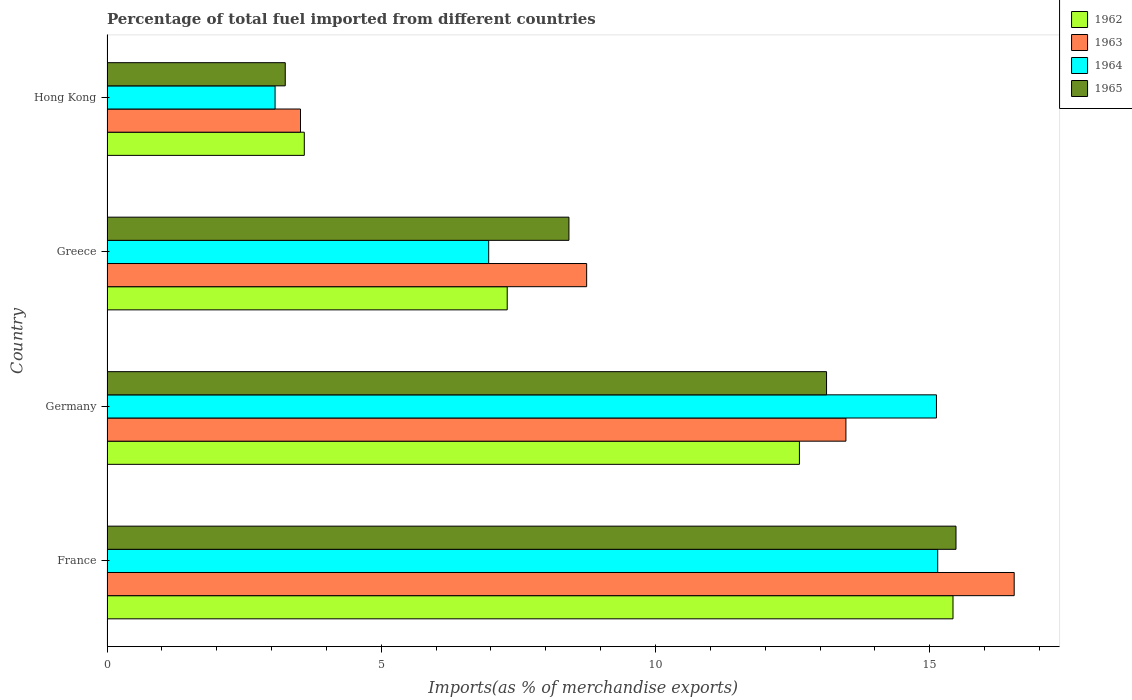How many different coloured bars are there?
Offer a very short reply. 4. How many groups of bars are there?
Your response must be concise. 4. Are the number of bars per tick equal to the number of legend labels?
Your answer should be very brief. Yes. How many bars are there on the 3rd tick from the top?
Keep it short and to the point. 4. How many bars are there on the 4th tick from the bottom?
Make the answer very short. 4. What is the label of the 1st group of bars from the top?
Offer a very short reply. Hong Kong. What is the percentage of imports to different countries in 1965 in France?
Keep it short and to the point. 15.48. Across all countries, what is the maximum percentage of imports to different countries in 1965?
Offer a very short reply. 15.48. Across all countries, what is the minimum percentage of imports to different countries in 1962?
Your response must be concise. 3.6. In which country was the percentage of imports to different countries in 1962 minimum?
Provide a short and direct response. Hong Kong. What is the total percentage of imports to different countries in 1962 in the graph?
Your answer should be very brief. 38.94. What is the difference between the percentage of imports to different countries in 1962 in Germany and that in Greece?
Your answer should be compact. 5.33. What is the difference between the percentage of imports to different countries in 1963 in Hong Kong and the percentage of imports to different countries in 1962 in Germany?
Offer a very short reply. -9.1. What is the average percentage of imports to different countries in 1963 per country?
Provide a short and direct response. 10.57. What is the difference between the percentage of imports to different countries in 1963 and percentage of imports to different countries in 1962 in Greece?
Keep it short and to the point. 1.45. In how many countries, is the percentage of imports to different countries in 1964 greater than 12 %?
Your answer should be compact. 2. What is the ratio of the percentage of imports to different countries in 1962 in France to that in Germany?
Provide a short and direct response. 1.22. What is the difference between the highest and the second highest percentage of imports to different countries in 1963?
Your answer should be compact. 3.07. What is the difference between the highest and the lowest percentage of imports to different countries in 1964?
Ensure brevity in your answer.  12.08. In how many countries, is the percentage of imports to different countries in 1965 greater than the average percentage of imports to different countries in 1965 taken over all countries?
Your answer should be compact. 2. What does the 3rd bar from the top in France represents?
Your answer should be very brief. 1963. What does the 4th bar from the bottom in Hong Kong represents?
Make the answer very short. 1965. Are all the bars in the graph horizontal?
Offer a very short reply. Yes. Are the values on the major ticks of X-axis written in scientific E-notation?
Offer a very short reply. No. Does the graph contain grids?
Ensure brevity in your answer.  No. How many legend labels are there?
Give a very brief answer. 4. How are the legend labels stacked?
Provide a short and direct response. Vertical. What is the title of the graph?
Offer a terse response. Percentage of total fuel imported from different countries. What is the label or title of the X-axis?
Provide a short and direct response. Imports(as % of merchandise exports). What is the Imports(as % of merchandise exports) of 1962 in France?
Your answer should be compact. 15.42. What is the Imports(as % of merchandise exports) of 1963 in France?
Make the answer very short. 16.54. What is the Imports(as % of merchandise exports) in 1964 in France?
Provide a succinct answer. 15.14. What is the Imports(as % of merchandise exports) of 1965 in France?
Ensure brevity in your answer.  15.48. What is the Imports(as % of merchandise exports) in 1962 in Germany?
Your response must be concise. 12.62. What is the Imports(as % of merchandise exports) in 1963 in Germany?
Give a very brief answer. 13.47. What is the Imports(as % of merchandise exports) of 1964 in Germany?
Make the answer very short. 15.12. What is the Imports(as % of merchandise exports) of 1965 in Germany?
Your answer should be very brief. 13.12. What is the Imports(as % of merchandise exports) of 1962 in Greece?
Offer a terse response. 7.3. What is the Imports(as % of merchandise exports) of 1963 in Greece?
Provide a short and direct response. 8.74. What is the Imports(as % of merchandise exports) of 1964 in Greece?
Make the answer very short. 6.96. What is the Imports(as % of merchandise exports) in 1965 in Greece?
Your response must be concise. 8.42. What is the Imports(as % of merchandise exports) in 1962 in Hong Kong?
Give a very brief answer. 3.6. What is the Imports(as % of merchandise exports) of 1963 in Hong Kong?
Your answer should be very brief. 3.53. What is the Imports(as % of merchandise exports) of 1964 in Hong Kong?
Your answer should be compact. 3.06. What is the Imports(as % of merchandise exports) in 1965 in Hong Kong?
Provide a short and direct response. 3.25. Across all countries, what is the maximum Imports(as % of merchandise exports) of 1962?
Offer a terse response. 15.42. Across all countries, what is the maximum Imports(as % of merchandise exports) of 1963?
Provide a succinct answer. 16.54. Across all countries, what is the maximum Imports(as % of merchandise exports) of 1964?
Give a very brief answer. 15.14. Across all countries, what is the maximum Imports(as % of merchandise exports) of 1965?
Ensure brevity in your answer.  15.48. Across all countries, what is the minimum Imports(as % of merchandise exports) of 1962?
Offer a very short reply. 3.6. Across all countries, what is the minimum Imports(as % of merchandise exports) of 1963?
Your answer should be compact. 3.53. Across all countries, what is the minimum Imports(as % of merchandise exports) of 1964?
Make the answer very short. 3.06. Across all countries, what is the minimum Imports(as % of merchandise exports) in 1965?
Make the answer very short. 3.25. What is the total Imports(as % of merchandise exports) of 1962 in the graph?
Offer a terse response. 38.94. What is the total Imports(as % of merchandise exports) in 1963 in the graph?
Make the answer very short. 42.28. What is the total Imports(as % of merchandise exports) in 1964 in the graph?
Keep it short and to the point. 40.29. What is the total Imports(as % of merchandise exports) of 1965 in the graph?
Your answer should be compact. 40.26. What is the difference between the Imports(as % of merchandise exports) in 1962 in France and that in Germany?
Give a very brief answer. 2.8. What is the difference between the Imports(as % of merchandise exports) of 1963 in France and that in Germany?
Keep it short and to the point. 3.07. What is the difference between the Imports(as % of merchandise exports) in 1964 in France and that in Germany?
Your answer should be very brief. 0.02. What is the difference between the Imports(as % of merchandise exports) of 1965 in France and that in Germany?
Your answer should be compact. 2.36. What is the difference between the Imports(as % of merchandise exports) in 1962 in France and that in Greece?
Your answer should be compact. 8.13. What is the difference between the Imports(as % of merchandise exports) in 1963 in France and that in Greece?
Give a very brief answer. 7.79. What is the difference between the Imports(as % of merchandise exports) of 1964 in France and that in Greece?
Make the answer very short. 8.19. What is the difference between the Imports(as % of merchandise exports) of 1965 in France and that in Greece?
Give a very brief answer. 7.06. What is the difference between the Imports(as % of merchandise exports) of 1962 in France and that in Hong Kong?
Keep it short and to the point. 11.83. What is the difference between the Imports(as % of merchandise exports) of 1963 in France and that in Hong Kong?
Your response must be concise. 13.01. What is the difference between the Imports(as % of merchandise exports) of 1964 in France and that in Hong Kong?
Ensure brevity in your answer.  12.08. What is the difference between the Imports(as % of merchandise exports) in 1965 in France and that in Hong Kong?
Make the answer very short. 12.23. What is the difference between the Imports(as % of merchandise exports) of 1962 in Germany and that in Greece?
Offer a very short reply. 5.33. What is the difference between the Imports(as % of merchandise exports) of 1963 in Germany and that in Greece?
Keep it short and to the point. 4.73. What is the difference between the Imports(as % of merchandise exports) of 1964 in Germany and that in Greece?
Your answer should be very brief. 8.16. What is the difference between the Imports(as % of merchandise exports) in 1965 in Germany and that in Greece?
Provide a short and direct response. 4.7. What is the difference between the Imports(as % of merchandise exports) in 1962 in Germany and that in Hong Kong?
Your answer should be compact. 9.03. What is the difference between the Imports(as % of merchandise exports) of 1963 in Germany and that in Hong Kong?
Provide a succinct answer. 9.94. What is the difference between the Imports(as % of merchandise exports) in 1964 in Germany and that in Hong Kong?
Keep it short and to the point. 12.06. What is the difference between the Imports(as % of merchandise exports) in 1965 in Germany and that in Hong Kong?
Offer a very short reply. 9.87. What is the difference between the Imports(as % of merchandise exports) of 1962 in Greece and that in Hong Kong?
Make the answer very short. 3.7. What is the difference between the Imports(as % of merchandise exports) in 1963 in Greece and that in Hong Kong?
Your response must be concise. 5.22. What is the difference between the Imports(as % of merchandise exports) of 1964 in Greece and that in Hong Kong?
Ensure brevity in your answer.  3.89. What is the difference between the Imports(as % of merchandise exports) in 1965 in Greece and that in Hong Kong?
Offer a terse response. 5.17. What is the difference between the Imports(as % of merchandise exports) of 1962 in France and the Imports(as % of merchandise exports) of 1963 in Germany?
Your answer should be very brief. 1.95. What is the difference between the Imports(as % of merchandise exports) in 1962 in France and the Imports(as % of merchandise exports) in 1964 in Germany?
Your response must be concise. 0.3. What is the difference between the Imports(as % of merchandise exports) of 1962 in France and the Imports(as % of merchandise exports) of 1965 in Germany?
Your answer should be compact. 2.31. What is the difference between the Imports(as % of merchandise exports) of 1963 in France and the Imports(as % of merchandise exports) of 1964 in Germany?
Provide a succinct answer. 1.42. What is the difference between the Imports(as % of merchandise exports) in 1963 in France and the Imports(as % of merchandise exports) in 1965 in Germany?
Give a very brief answer. 3.42. What is the difference between the Imports(as % of merchandise exports) in 1964 in France and the Imports(as % of merchandise exports) in 1965 in Germany?
Provide a short and direct response. 2.03. What is the difference between the Imports(as % of merchandise exports) of 1962 in France and the Imports(as % of merchandise exports) of 1963 in Greece?
Provide a short and direct response. 6.68. What is the difference between the Imports(as % of merchandise exports) of 1962 in France and the Imports(as % of merchandise exports) of 1964 in Greece?
Keep it short and to the point. 8.46. What is the difference between the Imports(as % of merchandise exports) in 1962 in France and the Imports(as % of merchandise exports) in 1965 in Greece?
Your answer should be compact. 7. What is the difference between the Imports(as % of merchandise exports) in 1963 in France and the Imports(as % of merchandise exports) in 1964 in Greece?
Make the answer very short. 9.58. What is the difference between the Imports(as % of merchandise exports) in 1963 in France and the Imports(as % of merchandise exports) in 1965 in Greece?
Make the answer very short. 8.12. What is the difference between the Imports(as % of merchandise exports) of 1964 in France and the Imports(as % of merchandise exports) of 1965 in Greece?
Your answer should be very brief. 6.72. What is the difference between the Imports(as % of merchandise exports) in 1962 in France and the Imports(as % of merchandise exports) in 1963 in Hong Kong?
Provide a short and direct response. 11.89. What is the difference between the Imports(as % of merchandise exports) in 1962 in France and the Imports(as % of merchandise exports) in 1964 in Hong Kong?
Ensure brevity in your answer.  12.36. What is the difference between the Imports(as % of merchandise exports) in 1962 in France and the Imports(as % of merchandise exports) in 1965 in Hong Kong?
Keep it short and to the point. 12.17. What is the difference between the Imports(as % of merchandise exports) of 1963 in France and the Imports(as % of merchandise exports) of 1964 in Hong Kong?
Your answer should be very brief. 13.47. What is the difference between the Imports(as % of merchandise exports) in 1963 in France and the Imports(as % of merchandise exports) in 1965 in Hong Kong?
Offer a very short reply. 13.29. What is the difference between the Imports(as % of merchandise exports) in 1964 in France and the Imports(as % of merchandise exports) in 1965 in Hong Kong?
Make the answer very short. 11.89. What is the difference between the Imports(as % of merchandise exports) in 1962 in Germany and the Imports(as % of merchandise exports) in 1963 in Greece?
Offer a terse response. 3.88. What is the difference between the Imports(as % of merchandise exports) of 1962 in Germany and the Imports(as % of merchandise exports) of 1964 in Greece?
Provide a short and direct response. 5.66. What is the difference between the Imports(as % of merchandise exports) of 1962 in Germany and the Imports(as % of merchandise exports) of 1965 in Greece?
Ensure brevity in your answer.  4.2. What is the difference between the Imports(as % of merchandise exports) in 1963 in Germany and the Imports(as % of merchandise exports) in 1964 in Greece?
Provide a short and direct response. 6.51. What is the difference between the Imports(as % of merchandise exports) in 1963 in Germany and the Imports(as % of merchandise exports) in 1965 in Greece?
Offer a terse response. 5.05. What is the difference between the Imports(as % of merchandise exports) of 1964 in Germany and the Imports(as % of merchandise exports) of 1965 in Greece?
Provide a succinct answer. 6.7. What is the difference between the Imports(as % of merchandise exports) in 1962 in Germany and the Imports(as % of merchandise exports) in 1963 in Hong Kong?
Provide a succinct answer. 9.1. What is the difference between the Imports(as % of merchandise exports) in 1962 in Germany and the Imports(as % of merchandise exports) in 1964 in Hong Kong?
Your response must be concise. 9.56. What is the difference between the Imports(as % of merchandise exports) of 1962 in Germany and the Imports(as % of merchandise exports) of 1965 in Hong Kong?
Keep it short and to the point. 9.37. What is the difference between the Imports(as % of merchandise exports) of 1963 in Germany and the Imports(as % of merchandise exports) of 1964 in Hong Kong?
Your answer should be compact. 10.41. What is the difference between the Imports(as % of merchandise exports) of 1963 in Germany and the Imports(as % of merchandise exports) of 1965 in Hong Kong?
Make the answer very short. 10.22. What is the difference between the Imports(as % of merchandise exports) of 1964 in Germany and the Imports(as % of merchandise exports) of 1965 in Hong Kong?
Provide a short and direct response. 11.87. What is the difference between the Imports(as % of merchandise exports) in 1962 in Greece and the Imports(as % of merchandise exports) in 1963 in Hong Kong?
Provide a short and direct response. 3.77. What is the difference between the Imports(as % of merchandise exports) of 1962 in Greece and the Imports(as % of merchandise exports) of 1964 in Hong Kong?
Your answer should be compact. 4.23. What is the difference between the Imports(as % of merchandise exports) of 1962 in Greece and the Imports(as % of merchandise exports) of 1965 in Hong Kong?
Your answer should be compact. 4.05. What is the difference between the Imports(as % of merchandise exports) of 1963 in Greece and the Imports(as % of merchandise exports) of 1964 in Hong Kong?
Your answer should be very brief. 5.68. What is the difference between the Imports(as % of merchandise exports) of 1963 in Greece and the Imports(as % of merchandise exports) of 1965 in Hong Kong?
Give a very brief answer. 5.49. What is the difference between the Imports(as % of merchandise exports) in 1964 in Greece and the Imports(as % of merchandise exports) in 1965 in Hong Kong?
Offer a very short reply. 3.71. What is the average Imports(as % of merchandise exports) of 1962 per country?
Keep it short and to the point. 9.73. What is the average Imports(as % of merchandise exports) of 1963 per country?
Ensure brevity in your answer.  10.57. What is the average Imports(as % of merchandise exports) of 1964 per country?
Offer a very short reply. 10.07. What is the average Imports(as % of merchandise exports) of 1965 per country?
Offer a very short reply. 10.07. What is the difference between the Imports(as % of merchandise exports) in 1962 and Imports(as % of merchandise exports) in 1963 in France?
Your answer should be compact. -1.12. What is the difference between the Imports(as % of merchandise exports) of 1962 and Imports(as % of merchandise exports) of 1964 in France?
Provide a succinct answer. 0.28. What is the difference between the Imports(as % of merchandise exports) of 1962 and Imports(as % of merchandise exports) of 1965 in France?
Offer a very short reply. -0.05. What is the difference between the Imports(as % of merchandise exports) of 1963 and Imports(as % of merchandise exports) of 1964 in France?
Your answer should be compact. 1.39. What is the difference between the Imports(as % of merchandise exports) in 1963 and Imports(as % of merchandise exports) in 1965 in France?
Offer a very short reply. 1.06. What is the difference between the Imports(as % of merchandise exports) of 1964 and Imports(as % of merchandise exports) of 1965 in France?
Your answer should be compact. -0.33. What is the difference between the Imports(as % of merchandise exports) in 1962 and Imports(as % of merchandise exports) in 1963 in Germany?
Provide a short and direct response. -0.85. What is the difference between the Imports(as % of merchandise exports) of 1962 and Imports(as % of merchandise exports) of 1964 in Germany?
Keep it short and to the point. -2.5. What is the difference between the Imports(as % of merchandise exports) in 1962 and Imports(as % of merchandise exports) in 1965 in Germany?
Offer a very short reply. -0.49. What is the difference between the Imports(as % of merchandise exports) of 1963 and Imports(as % of merchandise exports) of 1964 in Germany?
Offer a terse response. -1.65. What is the difference between the Imports(as % of merchandise exports) of 1963 and Imports(as % of merchandise exports) of 1965 in Germany?
Give a very brief answer. 0.35. What is the difference between the Imports(as % of merchandise exports) of 1964 and Imports(as % of merchandise exports) of 1965 in Germany?
Ensure brevity in your answer.  2. What is the difference between the Imports(as % of merchandise exports) in 1962 and Imports(as % of merchandise exports) in 1963 in Greece?
Offer a terse response. -1.45. What is the difference between the Imports(as % of merchandise exports) of 1962 and Imports(as % of merchandise exports) of 1964 in Greece?
Provide a short and direct response. 0.34. What is the difference between the Imports(as % of merchandise exports) of 1962 and Imports(as % of merchandise exports) of 1965 in Greece?
Your response must be concise. -1.13. What is the difference between the Imports(as % of merchandise exports) of 1963 and Imports(as % of merchandise exports) of 1964 in Greece?
Offer a terse response. 1.79. What is the difference between the Imports(as % of merchandise exports) in 1963 and Imports(as % of merchandise exports) in 1965 in Greece?
Offer a terse response. 0.32. What is the difference between the Imports(as % of merchandise exports) of 1964 and Imports(as % of merchandise exports) of 1965 in Greece?
Provide a short and direct response. -1.46. What is the difference between the Imports(as % of merchandise exports) of 1962 and Imports(as % of merchandise exports) of 1963 in Hong Kong?
Your answer should be very brief. 0.07. What is the difference between the Imports(as % of merchandise exports) in 1962 and Imports(as % of merchandise exports) in 1964 in Hong Kong?
Provide a succinct answer. 0.53. What is the difference between the Imports(as % of merchandise exports) of 1962 and Imports(as % of merchandise exports) of 1965 in Hong Kong?
Provide a short and direct response. 0.35. What is the difference between the Imports(as % of merchandise exports) of 1963 and Imports(as % of merchandise exports) of 1964 in Hong Kong?
Provide a short and direct response. 0.46. What is the difference between the Imports(as % of merchandise exports) of 1963 and Imports(as % of merchandise exports) of 1965 in Hong Kong?
Ensure brevity in your answer.  0.28. What is the difference between the Imports(as % of merchandise exports) in 1964 and Imports(as % of merchandise exports) in 1965 in Hong Kong?
Offer a very short reply. -0.19. What is the ratio of the Imports(as % of merchandise exports) in 1962 in France to that in Germany?
Keep it short and to the point. 1.22. What is the ratio of the Imports(as % of merchandise exports) of 1963 in France to that in Germany?
Keep it short and to the point. 1.23. What is the ratio of the Imports(as % of merchandise exports) in 1964 in France to that in Germany?
Keep it short and to the point. 1. What is the ratio of the Imports(as % of merchandise exports) of 1965 in France to that in Germany?
Offer a very short reply. 1.18. What is the ratio of the Imports(as % of merchandise exports) in 1962 in France to that in Greece?
Ensure brevity in your answer.  2.11. What is the ratio of the Imports(as % of merchandise exports) of 1963 in France to that in Greece?
Ensure brevity in your answer.  1.89. What is the ratio of the Imports(as % of merchandise exports) in 1964 in France to that in Greece?
Ensure brevity in your answer.  2.18. What is the ratio of the Imports(as % of merchandise exports) in 1965 in France to that in Greece?
Ensure brevity in your answer.  1.84. What is the ratio of the Imports(as % of merchandise exports) in 1962 in France to that in Hong Kong?
Your response must be concise. 4.29. What is the ratio of the Imports(as % of merchandise exports) in 1963 in France to that in Hong Kong?
Offer a terse response. 4.69. What is the ratio of the Imports(as % of merchandise exports) of 1964 in France to that in Hong Kong?
Keep it short and to the point. 4.94. What is the ratio of the Imports(as % of merchandise exports) of 1965 in France to that in Hong Kong?
Your response must be concise. 4.76. What is the ratio of the Imports(as % of merchandise exports) of 1962 in Germany to that in Greece?
Offer a very short reply. 1.73. What is the ratio of the Imports(as % of merchandise exports) of 1963 in Germany to that in Greece?
Your response must be concise. 1.54. What is the ratio of the Imports(as % of merchandise exports) of 1964 in Germany to that in Greece?
Keep it short and to the point. 2.17. What is the ratio of the Imports(as % of merchandise exports) in 1965 in Germany to that in Greece?
Make the answer very short. 1.56. What is the ratio of the Imports(as % of merchandise exports) of 1962 in Germany to that in Hong Kong?
Ensure brevity in your answer.  3.51. What is the ratio of the Imports(as % of merchandise exports) in 1963 in Germany to that in Hong Kong?
Give a very brief answer. 3.82. What is the ratio of the Imports(as % of merchandise exports) of 1964 in Germany to that in Hong Kong?
Provide a succinct answer. 4.94. What is the ratio of the Imports(as % of merchandise exports) in 1965 in Germany to that in Hong Kong?
Your answer should be compact. 4.04. What is the ratio of the Imports(as % of merchandise exports) in 1962 in Greece to that in Hong Kong?
Keep it short and to the point. 2.03. What is the ratio of the Imports(as % of merchandise exports) of 1963 in Greece to that in Hong Kong?
Provide a succinct answer. 2.48. What is the ratio of the Imports(as % of merchandise exports) of 1964 in Greece to that in Hong Kong?
Your response must be concise. 2.27. What is the ratio of the Imports(as % of merchandise exports) of 1965 in Greece to that in Hong Kong?
Provide a short and direct response. 2.59. What is the difference between the highest and the second highest Imports(as % of merchandise exports) in 1962?
Make the answer very short. 2.8. What is the difference between the highest and the second highest Imports(as % of merchandise exports) in 1963?
Provide a succinct answer. 3.07. What is the difference between the highest and the second highest Imports(as % of merchandise exports) of 1964?
Provide a succinct answer. 0.02. What is the difference between the highest and the second highest Imports(as % of merchandise exports) of 1965?
Offer a very short reply. 2.36. What is the difference between the highest and the lowest Imports(as % of merchandise exports) of 1962?
Make the answer very short. 11.83. What is the difference between the highest and the lowest Imports(as % of merchandise exports) in 1963?
Provide a short and direct response. 13.01. What is the difference between the highest and the lowest Imports(as % of merchandise exports) of 1964?
Offer a terse response. 12.08. What is the difference between the highest and the lowest Imports(as % of merchandise exports) in 1965?
Make the answer very short. 12.23. 